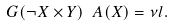<formula> <loc_0><loc_0><loc_500><loc_500>\ G ( \neg X \times Y ) \ A ( X ) = \nu l .</formula> 